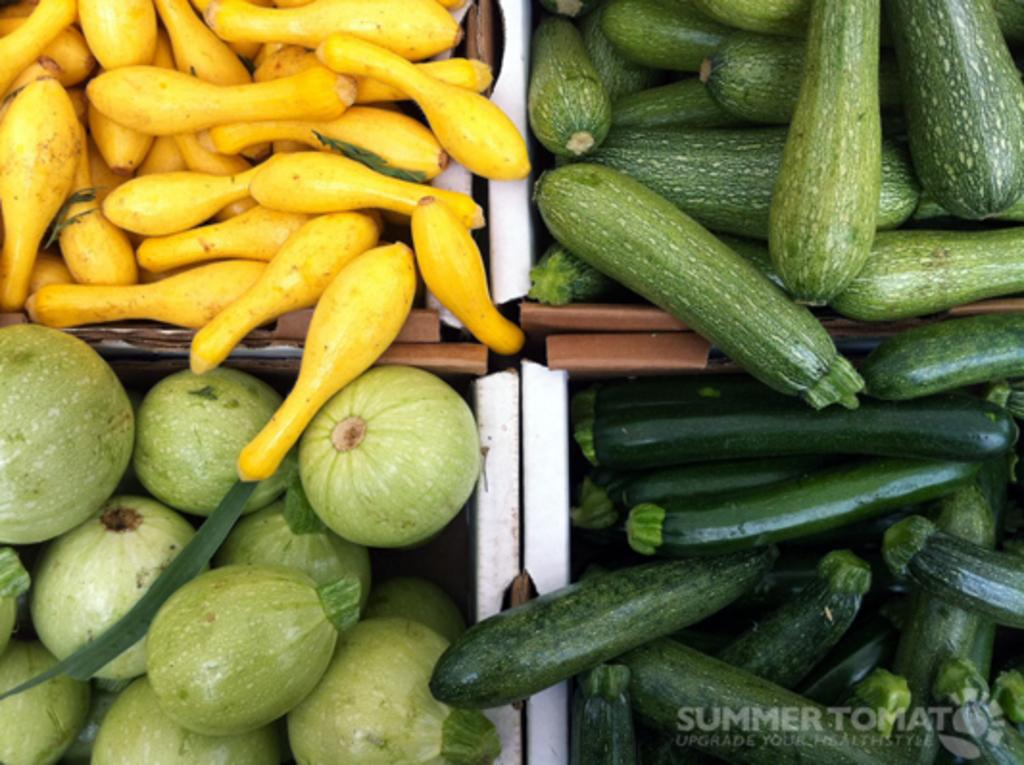What types of food items are present in the image? There are different types of vegetables in the image. How are the vegetables arranged or displayed in the image? The vegetables are in baskets. Is there any text or marking visible in the image? Yes, there is a watermark at the bottom right side of the image. What invention can be seen in the image? There is no invention present in the image; it features different types of vegetables in baskets. Can you see a crow in the image? No, there is no crow present in the image. 